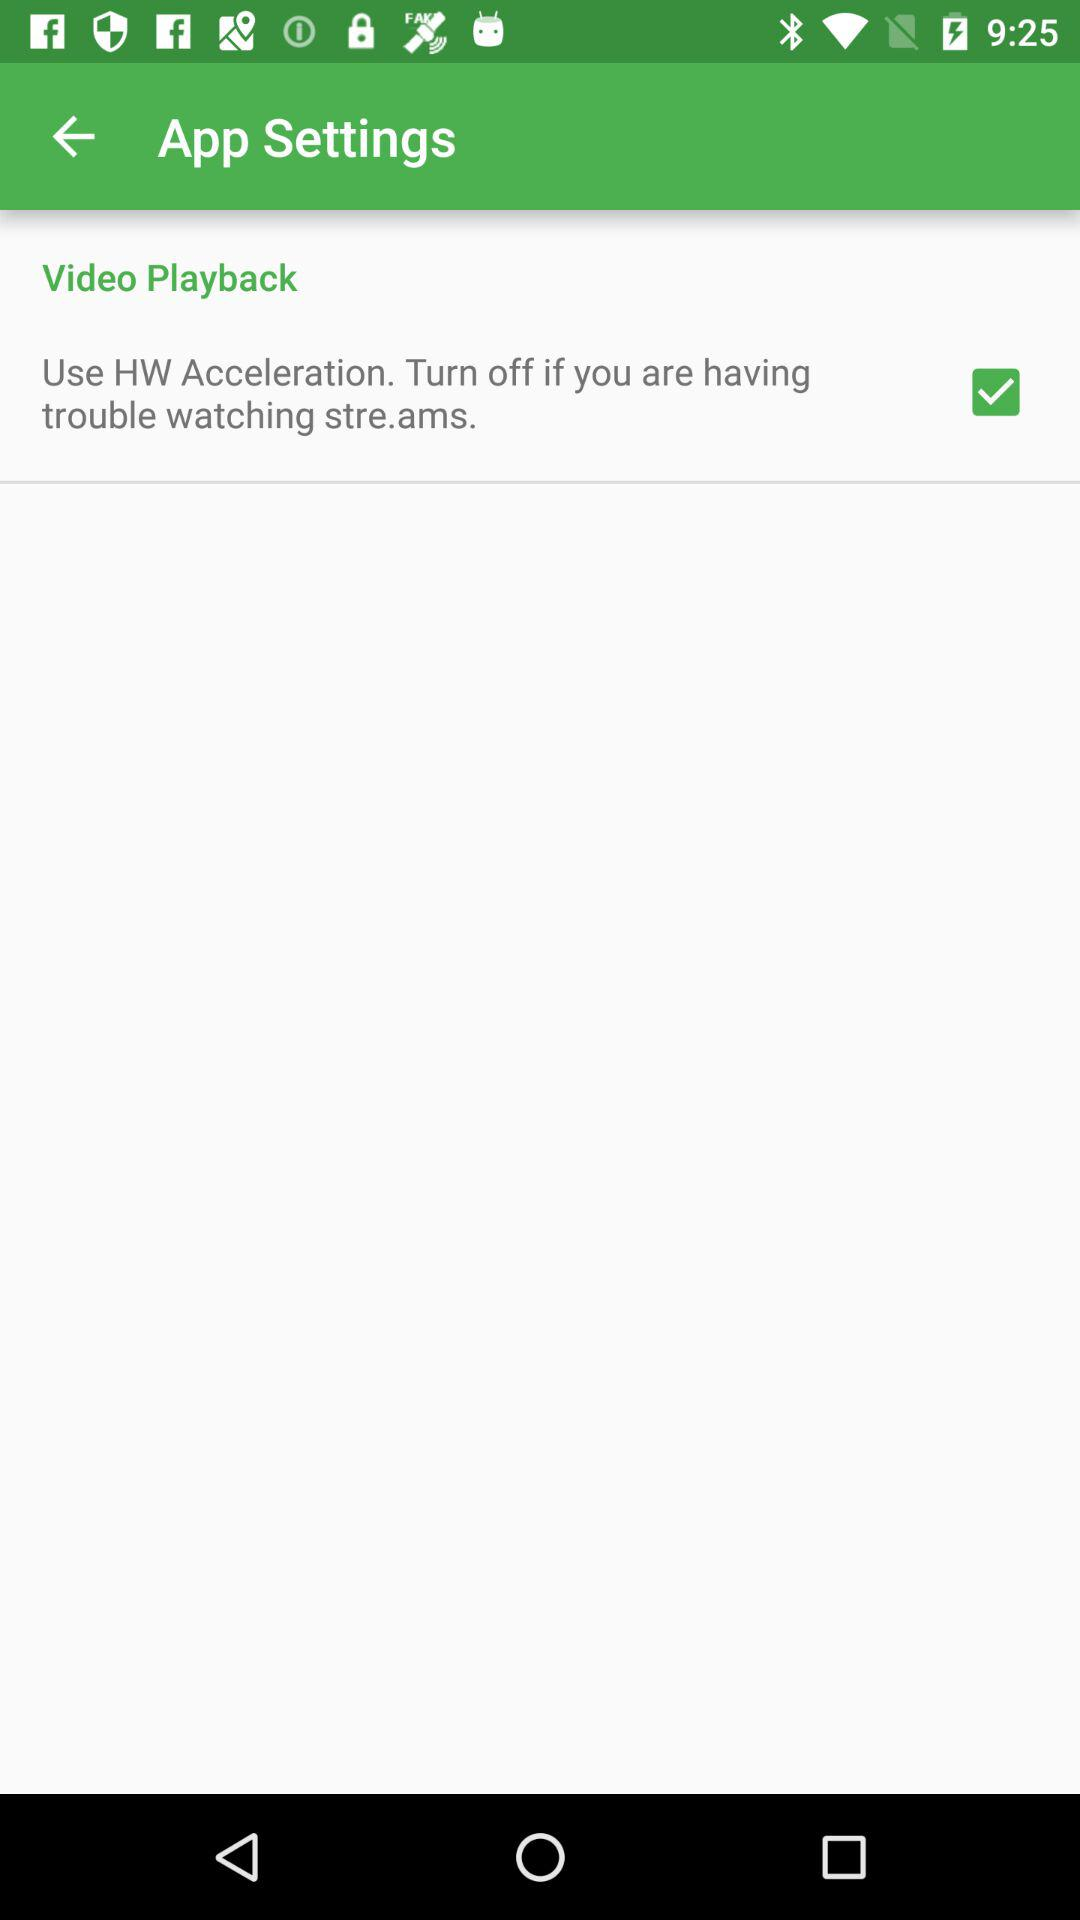What is the status of "Use HW Acceleration"? The status is "on". 